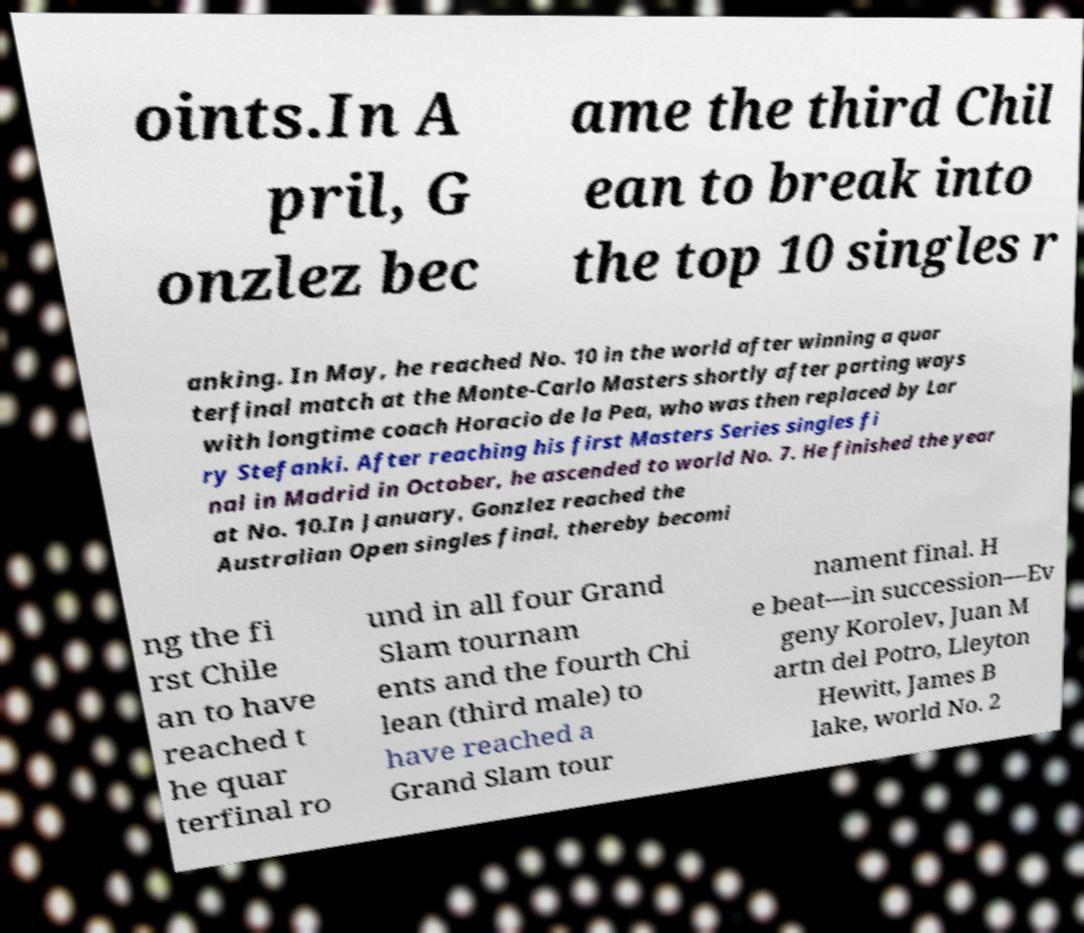Please read and relay the text visible in this image. What does it say? oints.In A pril, G onzlez bec ame the third Chil ean to break into the top 10 singles r anking. In May, he reached No. 10 in the world after winning a quar terfinal match at the Monte-Carlo Masters shortly after parting ways with longtime coach Horacio de la Pea, who was then replaced by Lar ry Stefanki. After reaching his first Masters Series singles fi nal in Madrid in October, he ascended to world No. 7. He finished the year at No. 10.In January, Gonzlez reached the Australian Open singles final, thereby becomi ng the fi rst Chile an to have reached t he quar terfinal ro und in all four Grand Slam tournam ents and the fourth Chi lean (third male) to have reached a Grand Slam tour nament final. H e beat—in succession—Ev geny Korolev, Juan M artn del Potro, Lleyton Hewitt, James B lake, world No. 2 